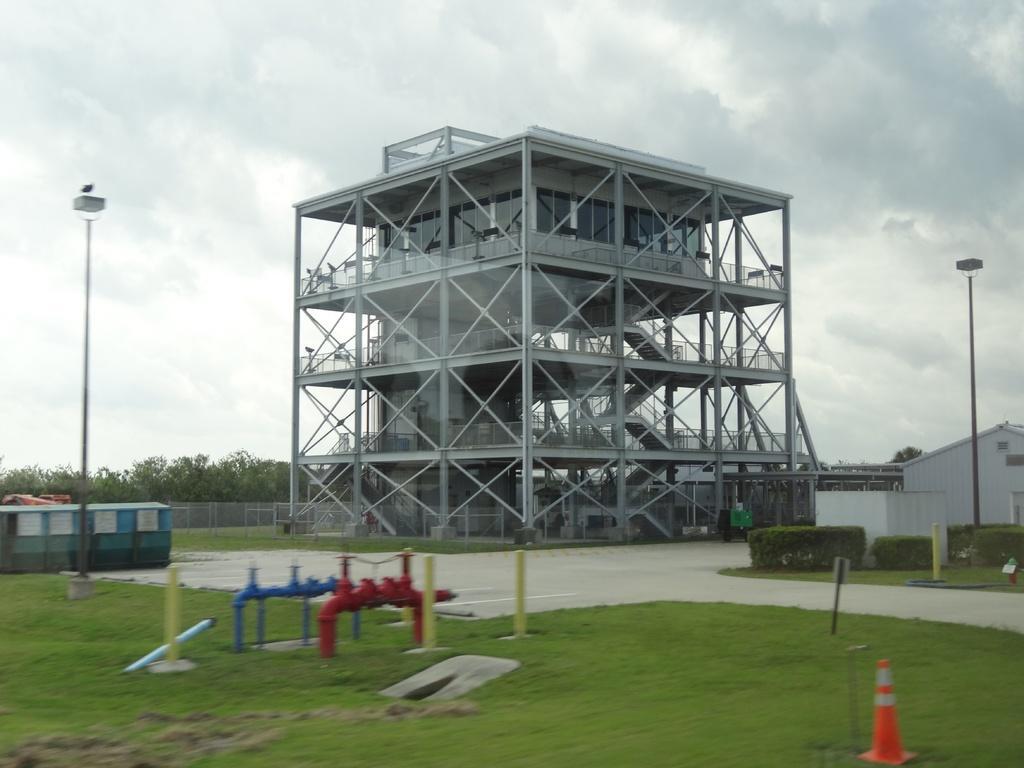Can you describe this image briefly? In the picture we can see a grass surface with two pipe connections one is red in color and one is blue in color and beside it, we can see a pole and in the background, we can see a building with poles and glasses to it and beside it, we can see a pole and shed and behind it we can see the railing wall and behind it we can see plants and sky with clouds. 